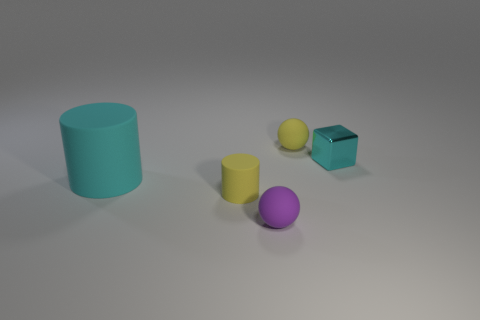Add 2 purple rubber spheres. How many objects exist? 7 Subtract all cubes. How many objects are left? 4 Add 3 small yellow matte spheres. How many small yellow matte spheres exist? 4 Subtract 0 green spheres. How many objects are left? 5 Subtract all brown balls. Subtract all yellow cylinders. How many balls are left? 2 Subtract all yellow rubber cylinders. Subtract all tiny purple metal cylinders. How many objects are left? 4 Add 1 cyan matte cylinders. How many cyan matte cylinders are left? 2 